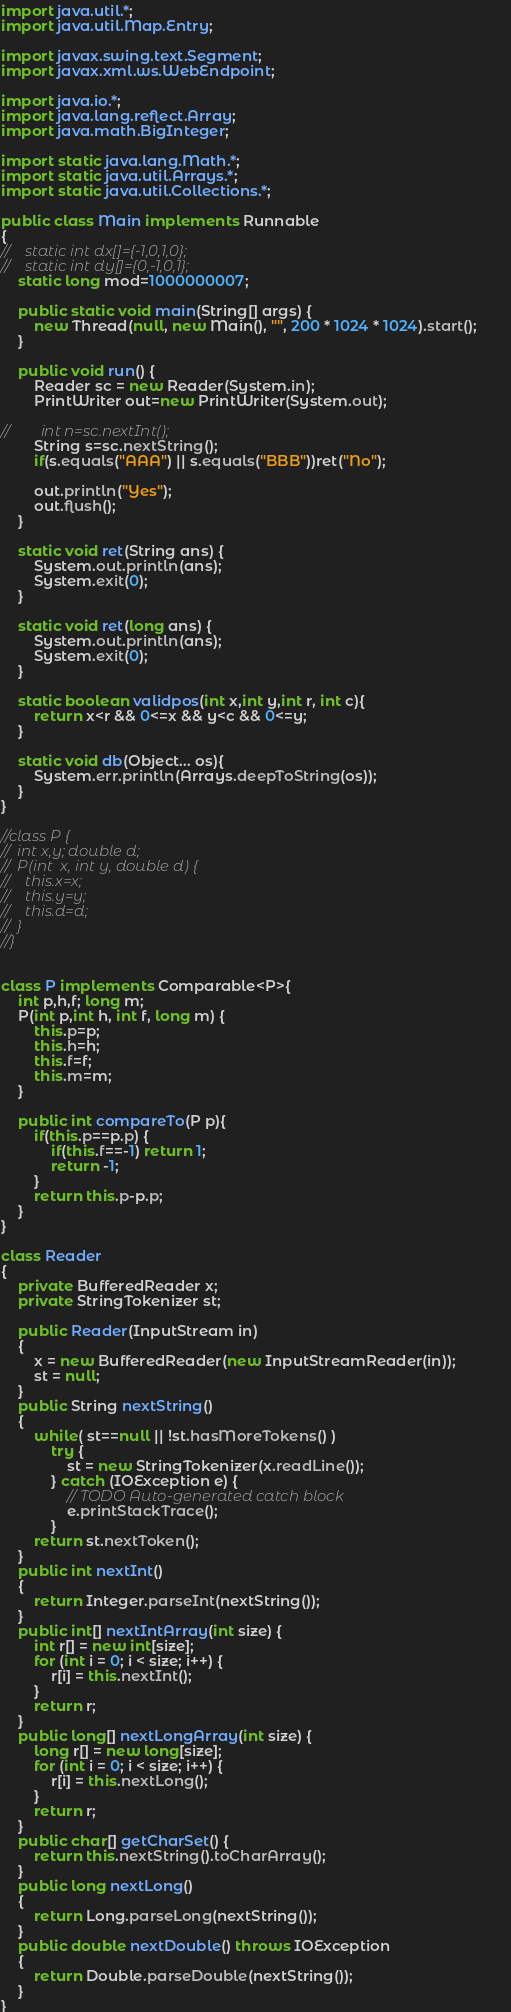Convert code to text. <code><loc_0><loc_0><loc_500><loc_500><_Java_>import java.util.*;
import java.util.Map.Entry;

import javax.swing.text.Segment;
import javax.xml.ws.WebEndpoint;

import java.io.*;
import java.lang.reflect.Array;
import java.math.BigInteger;

import static java.lang.Math.*;
import static java.util.Arrays.*;
import static java.util.Collections.*;

public class Main implements Runnable
{
//    static int dx[]={-1,0,1,0};
//    static int dy[]={0,-1,0,1};
    static long mod=1000000007;
    
    public static void main(String[] args) {        
        new Thread(null, new Main(), "", 200 * 1024 * 1024).start();        
    }

    public void run() {
        Reader sc = new Reader(System.in);
        PrintWriter out=new PrintWriter(System.out);

//        int n=sc.nextInt();
        String s=sc.nextString();
        if(s.equals("AAA") || s.equals("BBB"))ret("No");

        out.println("Yes");
     	out.flush();
    }
    
    static void ret(String ans) {
    	System.out.println(ans);
    	System.exit(0);
    }

    static void ret(long ans) {
    	System.out.println(ans);
    	System.exit(0);
    }
    
    static boolean validpos(int x,int y,int r, int c){
        return x<r && 0<=x && y<c && 0<=y;
    }

    static void db(Object... os){
        System.err.println(Arrays.deepToString(os));
    }
}

//class P {
//	int x,y; double d;
//	P(int  x, int y, double d) {
//	  this.x=x;
//	  this.y=y;
//	  this.d=d;
//	}
//}


class P implements Comparable<P>{
    int p,h,f; long m;
    P(int p,int h, int f, long m) {
    	this.p=p;
    	this.h=h;
    	this.f=f;
    	this.m=m;
    }

    public int compareTo(P p){
    	if(this.p==p.p) {
    		if(this.f==-1) return 1;
    		return -1;
    	}
        return this.p-p.p;
    }
}

class Reader
{ 
    private BufferedReader x;
    private StringTokenizer st;
    
    public Reader(InputStream in)
    {
        x = new BufferedReader(new InputStreamReader(in));
        st = null;
    }
    public String nextString()
    {
        while( st==null || !st.hasMoreTokens() )
			try {
				st = new StringTokenizer(x.readLine());
			} catch (IOException e) {
				// TODO Auto-generated catch block
				e.printStackTrace();
			}
        return st.nextToken();
    }
    public int nextInt()
    {
        return Integer.parseInt(nextString());
    }
    public int[] nextIntArray(int size) {
        int r[] = new int[size];
        for (int i = 0; i < size; i++) {
            r[i] = this.nextInt(); 
        }
        return r;
    }
    public long[] nextLongArray(int size) {
        long r[] = new long[size];
        for (int i = 0; i < size; i++) {
            r[i] = this.nextLong(); 
        }
        return r;
    }
    public char[] getCharSet() {
        return this.nextString().toCharArray();
    }    
    public long nextLong()
    {
        return Long.parseLong(nextString());
    }
    public double nextDouble() throws IOException
    {
        return Double.parseDouble(nextString());
    }
}
</code> 